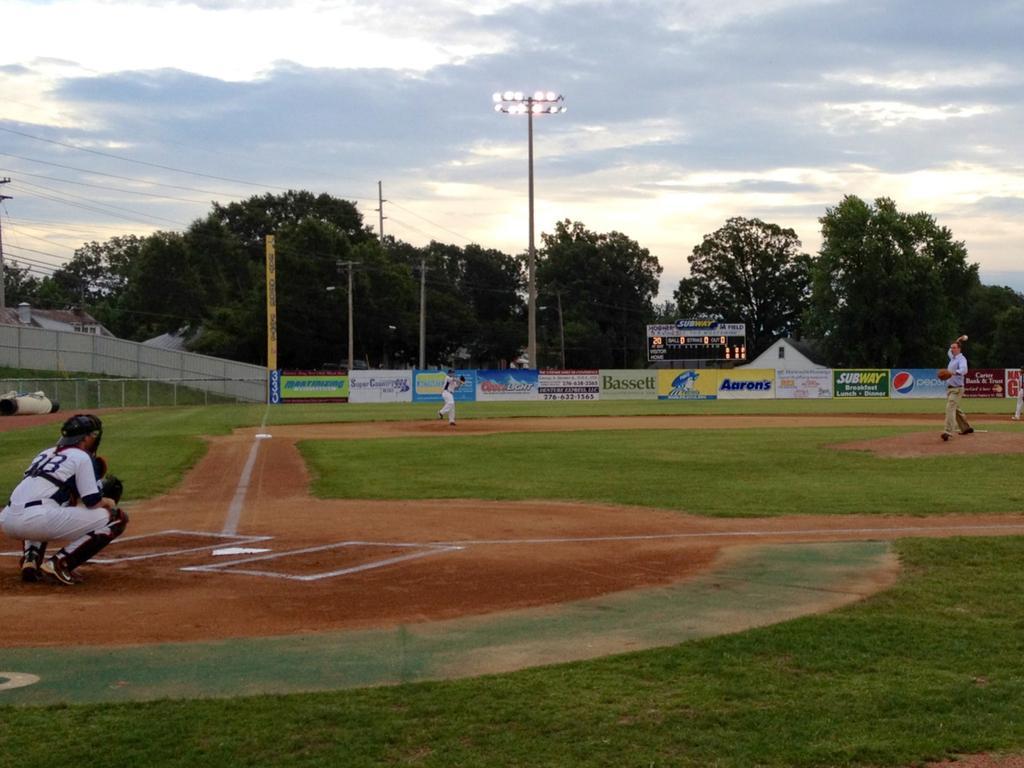Could you give a brief overview of what you see in this image? In this image there are people playing baseball. At the bottom of the image there is grass on the surface. In the background of the image there is a metal fence. There are banners. There is a display board. There are led lights. There are current poles with wires. There are buildings, trees. At the top of the image there is sky. 